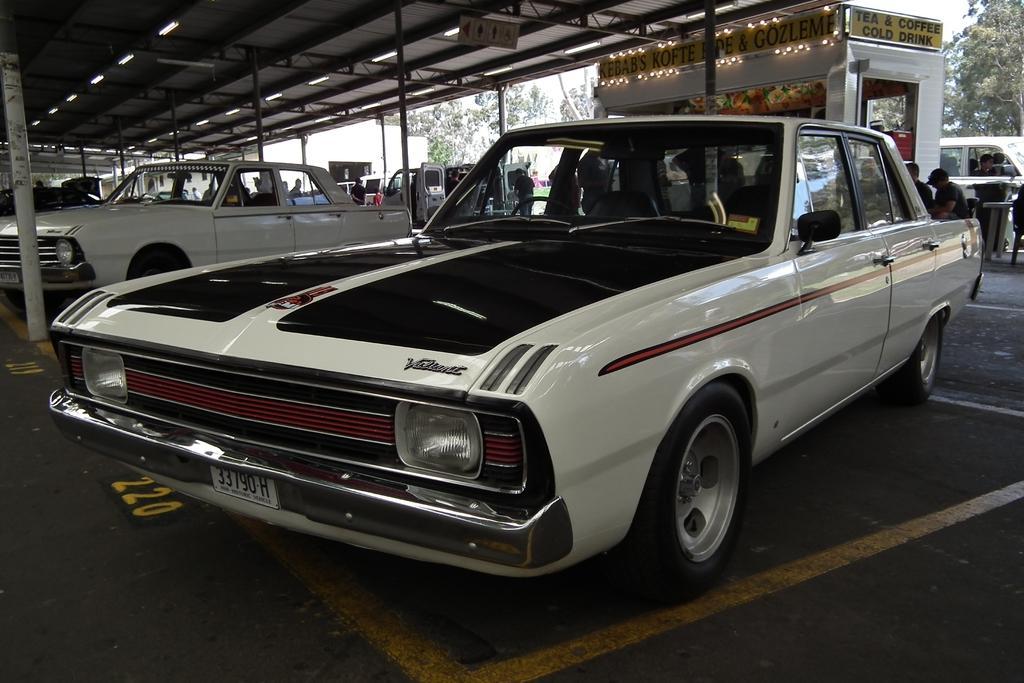Can you describe this image briefly? There are many cars. In the back there is a shed. On that something written. On the ceiling there are lights. In the background there are trees. Also there are people. 